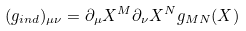Convert formula to latex. <formula><loc_0><loc_0><loc_500><loc_500>( g _ { i n d } ) _ { \mu \nu } = \partial _ { \mu } X ^ { M } \partial _ { \nu } X ^ { N } g _ { M N } ( X )</formula> 